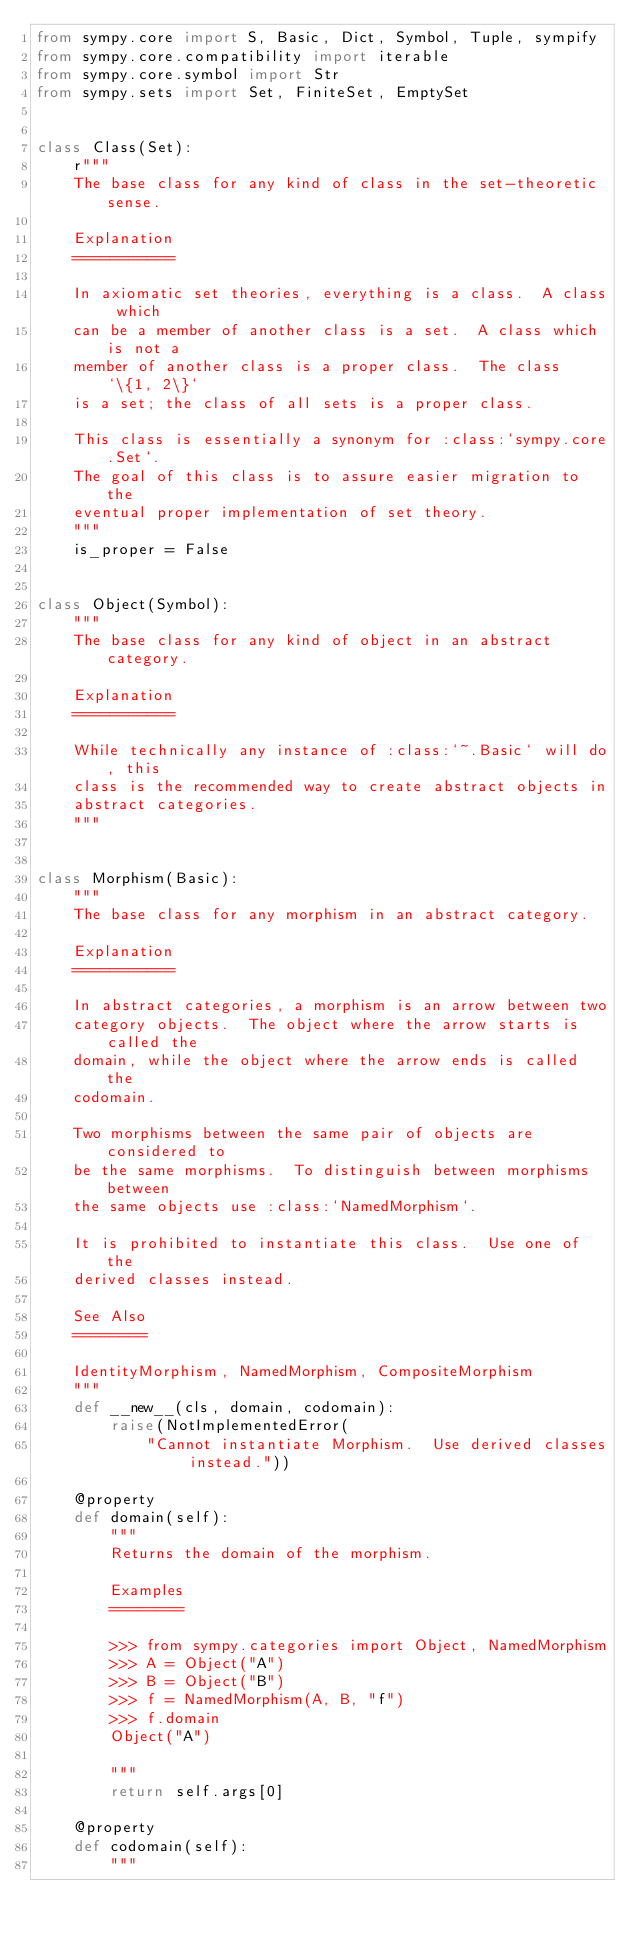<code> <loc_0><loc_0><loc_500><loc_500><_Python_>from sympy.core import S, Basic, Dict, Symbol, Tuple, sympify
from sympy.core.compatibility import iterable
from sympy.core.symbol import Str
from sympy.sets import Set, FiniteSet, EmptySet


class Class(Set):
    r"""
    The base class for any kind of class in the set-theoretic sense.

    Explanation
    ===========

    In axiomatic set theories, everything is a class.  A class which
    can be a member of another class is a set.  A class which is not a
    member of another class is a proper class.  The class `\{1, 2\}`
    is a set; the class of all sets is a proper class.

    This class is essentially a synonym for :class:`sympy.core.Set`.
    The goal of this class is to assure easier migration to the
    eventual proper implementation of set theory.
    """
    is_proper = False


class Object(Symbol):
    """
    The base class for any kind of object in an abstract category.

    Explanation
    ===========

    While technically any instance of :class:`~.Basic` will do, this
    class is the recommended way to create abstract objects in
    abstract categories.
    """


class Morphism(Basic):
    """
    The base class for any morphism in an abstract category.

    Explanation
    ===========

    In abstract categories, a morphism is an arrow between two
    category objects.  The object where the arrow starts is called the
    domain, while the object where the arrow ends is called the
    codomain.

    Two morphisms between the same pair of objects are considered to
    be the same morphisms.  To distinguish between morphisms between
    the same objects use :class:`NamedMorphism`.

    It is prohibited to instantiate this class.  Use one of the
    derived classes instead.

    See Also
    ========

    IdentityMorphism, NamedMorphism, CompositeMorphism
    """
    def __new__(cls, domain, codomain):
        raise(NotImplementedError(
            "Cannot instantiate Morphism.  Use derived classes instead."))

    @property
    def domain(self):
        """
        Returns the domain of the morphism.

        Examples
        ========

        >>> from sympy.categories import Object, NamedMorphism
        >>> A = Object("A")
        >>> B = Object("B")
        >>> f = NamedMorphism(A, B, "f")
        >>> f.domain
        Object("A")

        """
        return self.args[0]

    @property
    def codomain(self):
        """</code> 